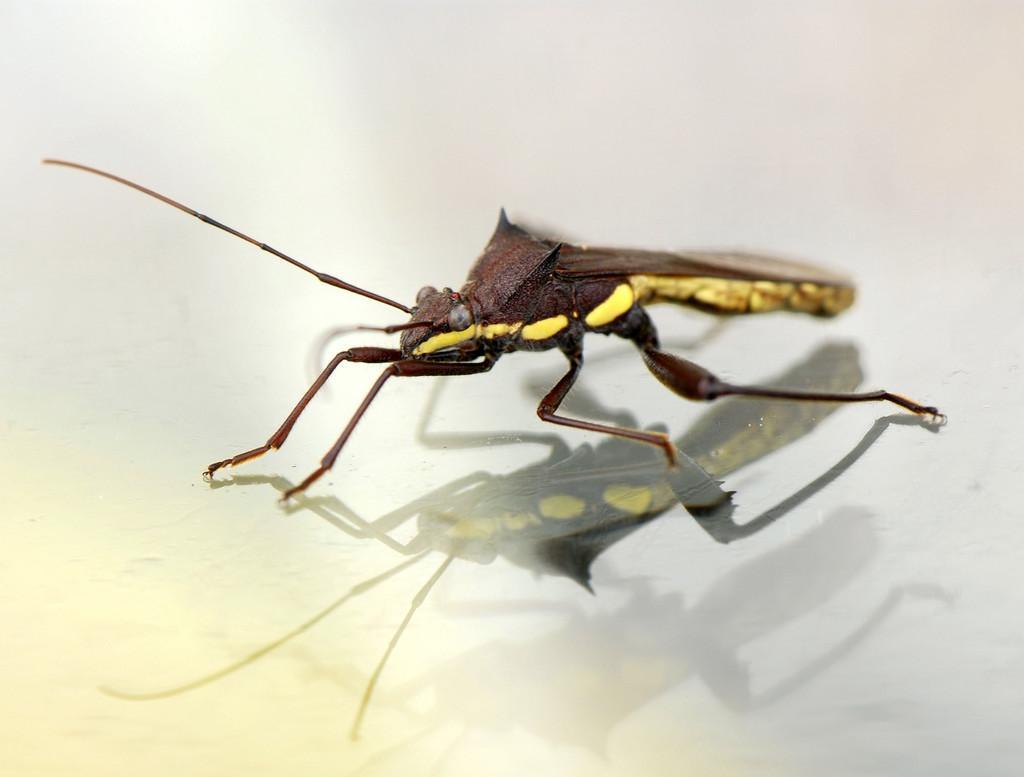Please provide a concise description of this image. In this picture there is a mosquito who is standing on the glass. We can see reflection in the glass. 